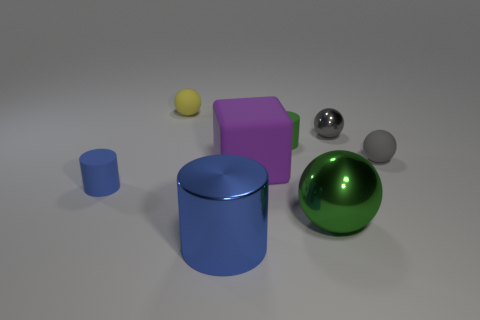Subtract all large metal balls. How many balls are left? 3 Add 2 small red things. How many objects exist? 10 Subtract all blue cylinders. How many cylinders are left? 1 Subtract all cubes. How many objects are left? 7 Subtract 1 cubes. How many cubes are left? 0 Subtract all cyan balls. Subtract all blue blocks. How many balls are left? 4 Subtract all cyan blocks. How many yellow cylinders are left? 0 Subtract all red metallic cylinders. Subtract all rubber cubes. How many objects are left? 7 Add 6 blue cylinders. How many blue cylinders are left? 8 Add 4 tiny blue objects. How many tiny blue objects exist? 5 